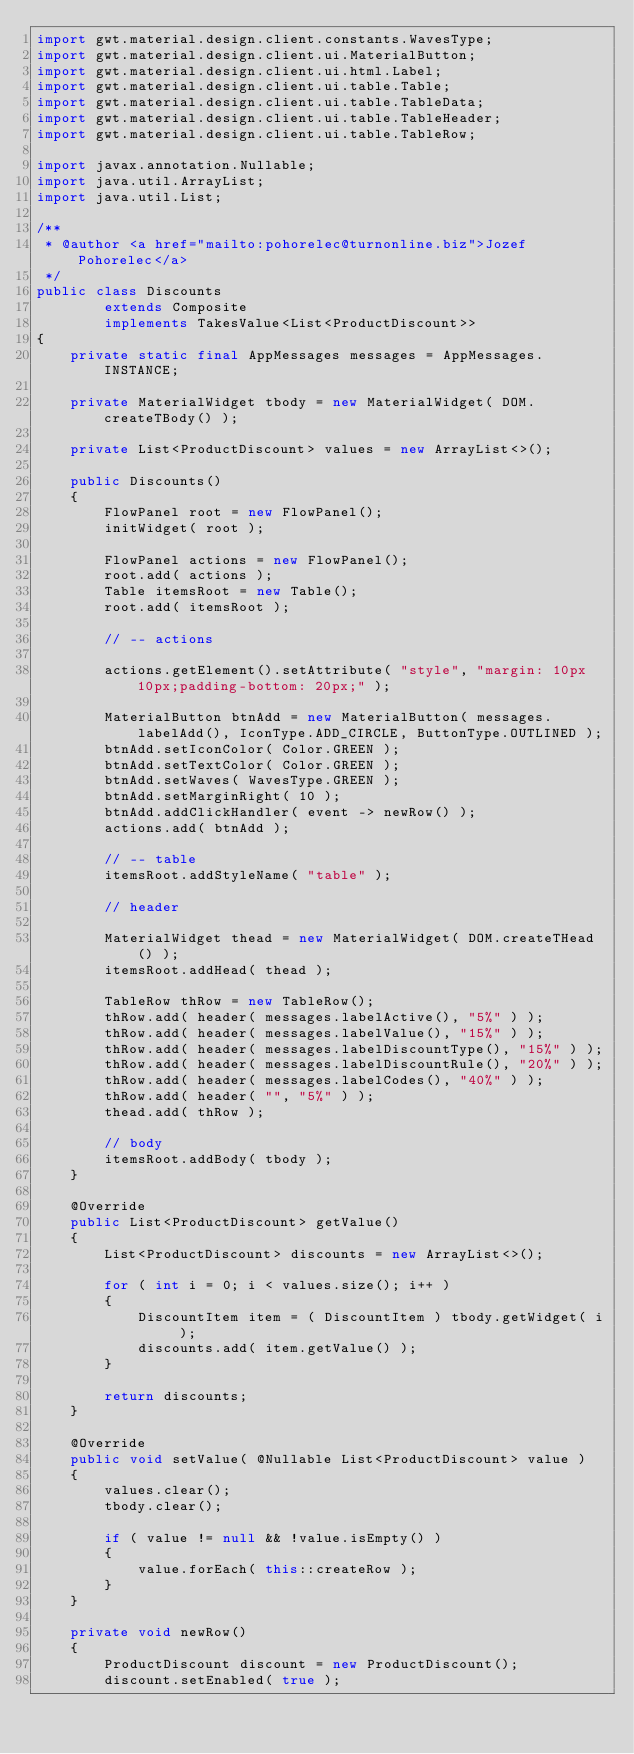<code> <loc_0><loc_0><loc_500><loc_500><_Java_>import gwt.material.design.client.constants.WavesType;
import gwt.material.design.client.ui.MaterialButton;
import gwt.material.design.client.ui.html.Label;
import gwt.material.design.client.ui.table.Table;
import gwt.material.design.client.ui.table.TableData;
import gwt.material.design.client.ui.table.TableHeader;
import gwt.material.design.client.ui.table.TableRow;

import javax.annotation.Nullable;
import java.util.ArrayList;
import java.util.List;

/**
 * @author <a href="mailto:pohorelec@turnonline.biz">Jozef Pohorelec</a>
 */
public class Discounts
        extends Composite
        implements TakesValue<List<ProductDiscount>>
{
    private static final AppMessages messages = AppMessages.INSTANCE;

    private MaterialWidget tbody = new MaterialWidget( DOM.createTBody() );

    private List<ProductDiscount> values = new ArrayList<>();

    public Discounts()
    {
        FlowPanel root = new FlowPanel();
        initWidget( root );

        FlowPanel actions = new FlowPanel();
        root.add( actions );
        Table itemsRoot = new Table();
        root.add( itemsRoot );

        // -- actions

        actions.getElement().setAttribute( "style", "margin: 10px 10px;padding-bottom: 20px;" );

        MaterialButton btnAdd = new MaterialButton( messages.labelAdd(), IconType.ADD_CIRCLE, ButtonType.OUTLINED );
        btnAdd.setIconColor( Color.GREEN );
        btnAdd.setTextColor( Color.GREEN );
        btnAdd.setWaves( WavesType.GREEN );
        btnAdd.setMarginRight( 10 );
        btnAdd.addClickHandler( event -> newRow() );
        actions.add( btnAdd );

        // -- table
        itemsRoot.addStyleName( "table" );

        // header

        MaterialWidget thead = new MaterialWidget( DOM.createTHead() );
        itemsRoot.addHead( thead );

        TableRow thRow = new TableRow();
        thRow.add( header( messages.labelActive(), "5%" ) );
        thRow.add( header( messages.labelValue(), "15%" ) );
        thRow.add( header( messages.labelDiscountType(), "15%" ) );
        thRow.add( header( messages.labelDiscountRule(), "20%" ) );
        thRow.add( header( messages.labelCodes(), "40%" ) );
        thRow.add( header( "", "5%" ) );
        thead.add( thRow );

        // body
        itemsRoot.addBody( tbody );
    }

    @Override
    public List<ProductDiscount> getValue()
    {
        List<ProductDiscount> discounts = new ArrayList<>();

        for ( int i = 0; i < values.size(); i++ )
        {
            DiscountItem item = ( DiscountItem ) tbody.getWidget( i );
            discounts.add( item.getValue() );
        }

        return discounts;
    }

    @Override
    public void setValue( @Nullable List<ProductDiscount> value )
    {
        values.clear();
        tbody.clear();

        if ( value != null && !value.isEmpty() )
        {
            value.forEach( this::createRow );
        }
    }

    private void newRow()
    {
        ProductDiscount discount = new ProductDiscount();
        discount.setEnabled( true );</code> 